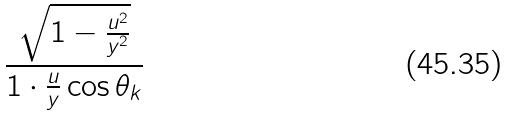<formula> <loc_0><loc_0><loc_500><loc_500>\frac { \sqrt { 1 - \frac { u ^ { 2 } } { y ^ { 2 } } } } { 1 \cdot \frac { u } { y } \cos \theta _ { k } }</formula> 